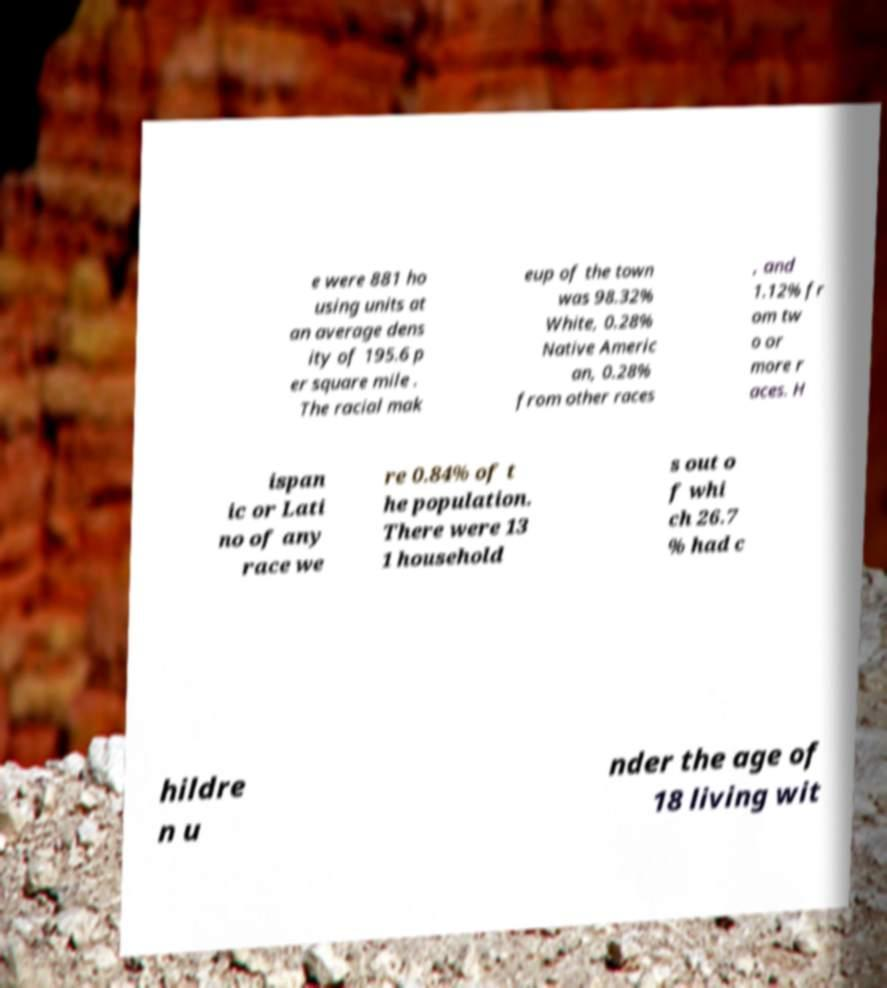Could you assist in decoding the text presented in this image and type it out clearly? e were 881 ho using units at an average dens ity of 195.6 p er square mile . The racial mak eup of the town was 98.32% White, 0.28% Native Americ an, 0.28% from other races , and 1.12% fr om tw o or more r aces. H ispan ic or Lati no of any race we re 0.84% of t he population. There were 13 1 household s out o f whi ch 26.7 % had c hildre n u nder the age of 18 living wit 